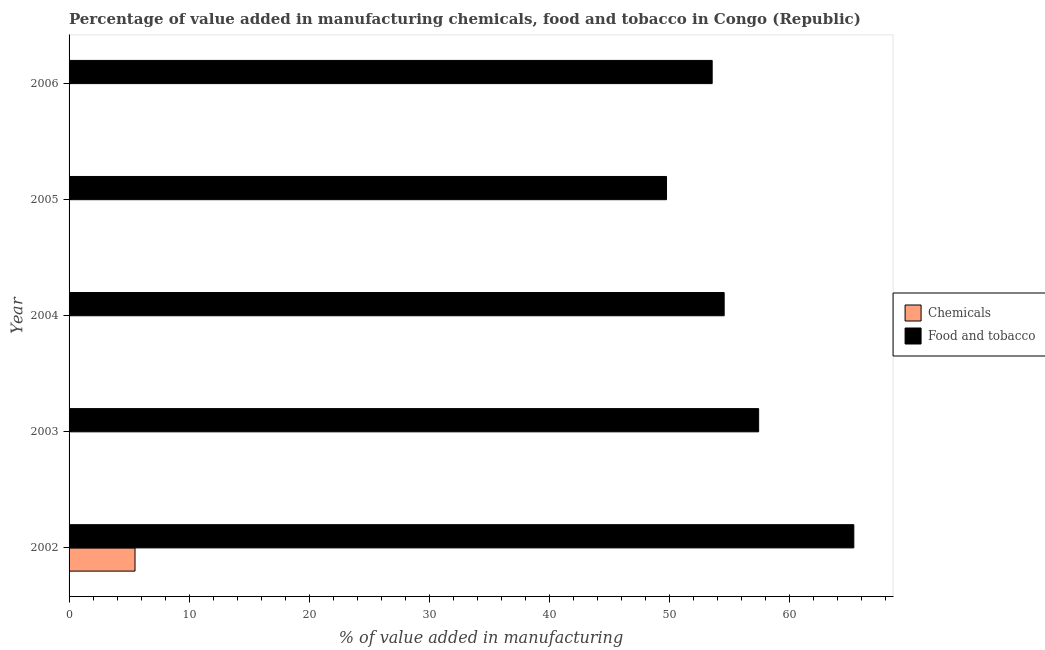Are the number of bars per tick equal to the number of legend labels?
Make the answer very short. No. Are the number of bars on each tick of the Y-axis equal?
Provide a succinct answer. No. How many bars are there on the 1st tick from the top?
Offer a terse response. 1. How many bars are there on the 1st tick from the bottom?
Your answer should be compact. 2. What is the value added by manufacturing food and tobacco in 2003?
Your response must be concise. 57.44. Across all years, what is the maximum value added by  manufacturing chemicals?
Offer a very short reply. 5.49. Across all years, what is the minimum value added by manufacturing food and tobacco?
Provide a short and direct response. 49.77. What is the total value added by  manufacturing chemicals in the graph?
Your answer should be very brief. 5.49. What is the difference between the value added by manufacturing food and tobacco in 2003 and that in 2005?
Offer a terse response. 7.67. What is the difference between the value added by manufacturing food and tobacco in 2005 and the value added by  manufacturing chemicals in 2003?
Ensure brevity in your answer.  49.77. What is the average value added by manufacturing food and tobacco per year?
Provide a succinct answer. 56.14. In the year 2002, what is the difference between the value added by manufacturing food and tobacco and value added by  manufacturing chemicals?
Ensure brevity in your answer.  59.88. In how many years, is the value added by  manufacturing chemicals greater than 24 %?
Your response must be concise. 0. What is the ratio of the value added by manufacturing food and tobacco in 2005 to that in 2006?
Keep it short and to the point. 0.93. What is the difference between the highest and the second highest value added by manufacturing food and tobacco?
Provide a succinct answer. 7.93. What is the difference between the highest and the lowest value added by  manufacturing chemicals?
Ensure brevity in your answer.  5.49. Is the sum of the value added by manufacturing food and tobacco in 2005 and 2006 greater than the maximum value added by  manufacturing chemicals across all years?
Your answer should be compact. Yes. How many bars are there?
Provide a succinct answer. 6. Are all the bars in the graph horizontal?
Provide a short and direct response. Yes. Are the values on the major ticks of X-axis written in scientific E-notation?
Offer a terse response. No. Does the graph contain any zero values?
Ensure brevity in your answer.  Yes. Where does the legend appear in the graph?
Your response must be concise. Center right. How many legend labels are there?
Keep it short and to the point. 2. How are the legend labels stacked?
Offer a terse response. Vertical. What is the title of the graph?
Make the answer very short. Percentage of value added in manufacturing chemicals, food and tobacco in Congo (Republic). What is the label or title of the X-axis?
Your answer should be very brief. % of value added in manufacturing. What is the % of value added in manufacturing in Chemicals in 2002?
Your response must be concise. 5.49. What is the % of value added in manufacturing of Food and tobacco in 2002?
Provide a short and direct response. 65.37. What is the % of value added in manufacturing of Food and tobacco in 2003?
Your answer should be very brief. 57.44. What is the % of value added in manufacturing in Chemicals in 2004?
Ensure brevity in your answer.  0. What is the % of value added in manufacturing of Food and tobacco in 2004?
Provide a succinct answer. 54.57. What is the % of value added in manufacturing of Food and tobacco in 2005?
Provide a short and direct response. 49.77. What is the % of value added in manufacturing in Chemicals in 2006?
Provide a short and direct response. 0. What is the % of value added in manufacturing in Food and tobacco in 2006?
Offer a terse response. 53.57. Across all years, what is the maximum % of value added in manufacturing in Chemicals?
Ensure brevity in your answer.  5.49. Across all years, what is the maximum % of value added in manufacturing in Food and tobacco?
Ensure brevity in your answer.  65.37. Across all years, what is the minimum % of value added in manufacturing of Food and tobacco?
Offer a very short reply. 49.77. What is the total % of value added in manufacturing in Chemicals in the graph?
Give a very brief answer. 5.49. What is the total % of value added in manufacturing in Food and tobacco in the graph?
Keep it short and to the point. 280.72. What is the difference between the % of value added in manufacturing of Food and tobacco in 2002 and that in 2003?
Provide a succinct answer. 7.93. What is the difference between the % of value added in manufacturing of Food and tobacco in 2002 and that in 2004?
Provide a succinct answer. 10.8. What is the difference between the % of value added in manufacturing of Food and tobacco in 2002 and that in 2005?
Your answer should be compact. 15.6. What is the difference between the % of value added in manufacturing in Food and tobacco in 2002 and that in 2006?
Ensure brevity in your answer.  11.8. What is the difference between the % of value added in manufacturing of Food and tobacco in 2003 and that in 2004?
Make the answer very short. 2.87. What is the difference between the % of value added in manufacturing in Food and tobacco in 2003 and that in 2005?
Provide a short and direct response. 7.67. What is the difference between the % of value added in manufacturing in Food and tobacco in 2003 and that in 2006?
Keep it short and to the point. 3.87. What is the difference between the % of value added in manufacturing in Food and tobacco in 2004 and that in 2005?
Make the answer very short. 4.8. What is the difference between the % of value added in manufacturing of Food and tobacco in 2005 and that in 2006?
Provide a short and direct response. -3.8. What is the difference between the % of value added in manufacturing of Chemicals in 2002 and the % of value added in manufacturing of Food and tobacco in 2003?
Keep it short and to the point. -51.95. What is the difference between the % of value added in manufacturing of Chemicals in 2002 and the % of value added in manufacturing of Food and tobacco in 2004?
Provide a succinct answer. -49.08. What is the difference between the % of value added in manufacturing in Chemicals in 2002 and the % of value added in manufacturing in Food and tobacco in 2005?
Provide a succinct answer. -44.27. What is the difference between the % of value added in manufacturing of Chemicals in 2002 and the % of value added in manufacturing of Food and tobacco in 2006?
Make the answer very short. -48.08. What is the average % of value added in manufacturing of Chemicals per year?
Give a very brief answer. 1.1. What is the average % of value added in manufacturing in Food and tobacco per year?
Your answer should be very brief. 56.14. In the year 2002, what is the difference between the % of value added in manufacturing of Chemicals and % of value added in manufacturing of Food and tobacco?
Offer a very short reply. -59.88. What is the ratio of the % of value added in manufacturing in Food and tobacco in 2002 to that in 2003?
Give a very brief answer. 1.14. What is the ratio of the % of value added in manufacturing of Food and tobacco in 2002 to that in 2004?
Your response must be concise. 1.2. What is the ratio of the % of value added in manufacturing of Food and tobacco in 2002 to that in 2005?
Your answer should be compact. 1.31. What is the ratio of the % of value added in manufacturing of Food and tobacco in 2002 to that in 2006?
Keep it short and to the point. 1.22. What is the ratio of the % of value added in manufacturing of Food and tobacco in 2003 to that in 2004?
Your answer should be very brief. 1.05. What is the ratio of the % of value added in manufacturing in Food and tobacco in 2003 to that in 2005?
Give a very brief answer. 1.15. What is the ratio of the % of value added in manufacturing of Food and tobacco in 2003 to that in 2006?
Make the answer very short. 1.07. What is the ratio of the % of value added in manufacturing of Food and tobacco in 2004 to that in 2005?
Your answer should be very brief. 1.1. What is the ratio of the % of value added in manufacturing in Food and tobacco in 2004 to that in 2006?
Keep it short and to the point. 1.02. What is the ratio of the % of value added in manufacturing in Food and tobacco in 2005 to that in 2006?
Your answer should be compact. 0.93. What is the difference between the highest and the second highest % of value added in manufacturing in Food and tobacco?
Ensure brevity in your answer.  7.93. What is the difference between the highest and the lowest % of value added in manufacturing of Chemicals?
Your answer should be compact. 5.49. What is the difference between the highest and the lowest % of value added in manufacturing in Food and tobacco?
Make the answer very short. 15.6. 